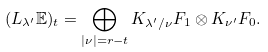Convert formula to latex. <formula><loc_0><loc_0><loc_500><loc_500>( L _ { \lambda ^ { \prime } } \mathbb { E } ) _ { t } = \bigoplus _ { | \nu | = r - t } K _ { \lambda ^ { \prime } / \nu } F _ { 1 } \otimes K _ { \nu ^ { \prime } } F _ { 0 } .</formula> 